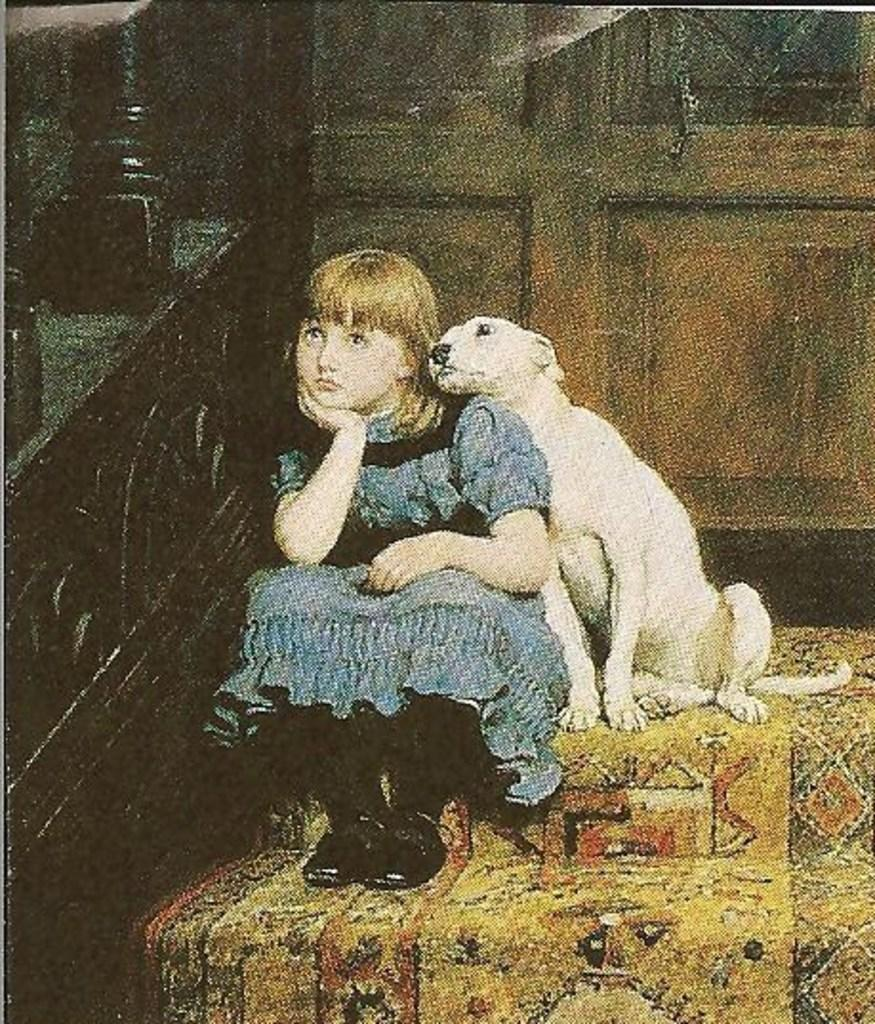What is present in the image along with the child? There is a dog in the image along with the child. Where are the child and dog located in the image? The child and dog are sitting on the left side corner of the image. What can be seen in the background of the image? There is a wall in the background of the image. What time of day is it in the image, as indicated by the clock? There is no clock present in the image, so it is not possible to determine the time of day. 